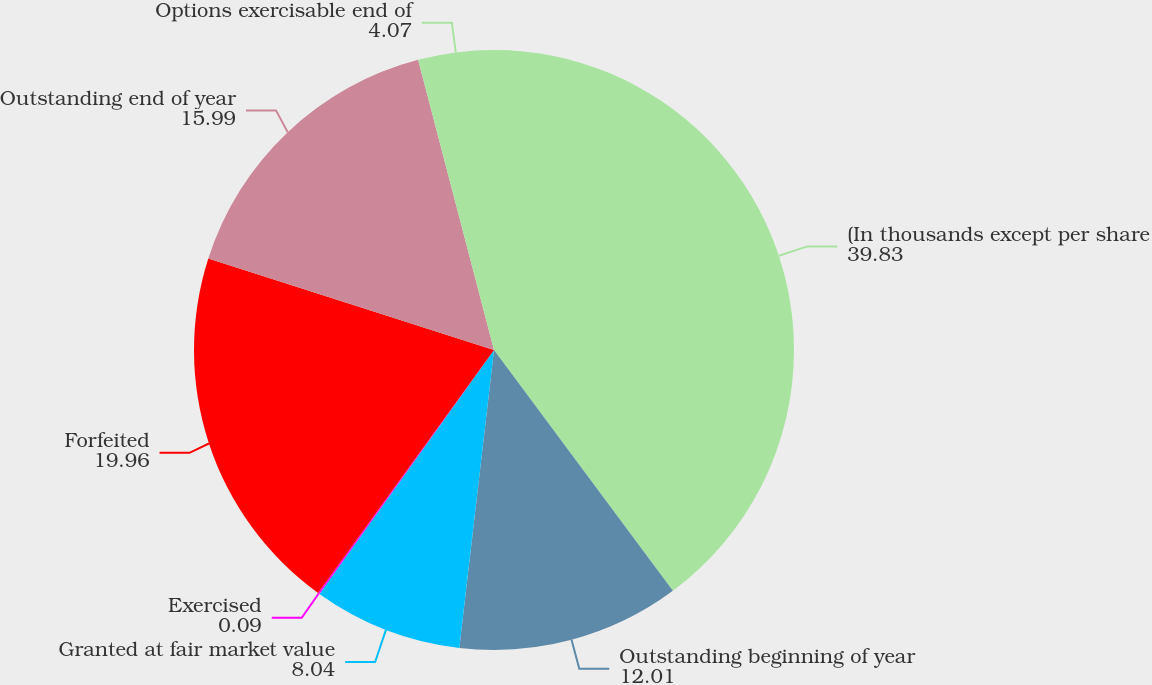<chart> <loc_0><loc_0><loc_500><loc_500><pie_chart><fcel>(In thousands except per share<fcel>Outstanding beginning of year<fcel>Granted at fair market value<fcel>Exercised<fcel>Forfeited<fcel>Outstanding end of year<fcel>Options exercisable end of<nl><fcel>39.83%<fcel>12.01%<fcel>8.04%<fcel>0.09%<fcel>19.96%<fcel>15.99%<fcel>4.07%<nl></chart> 